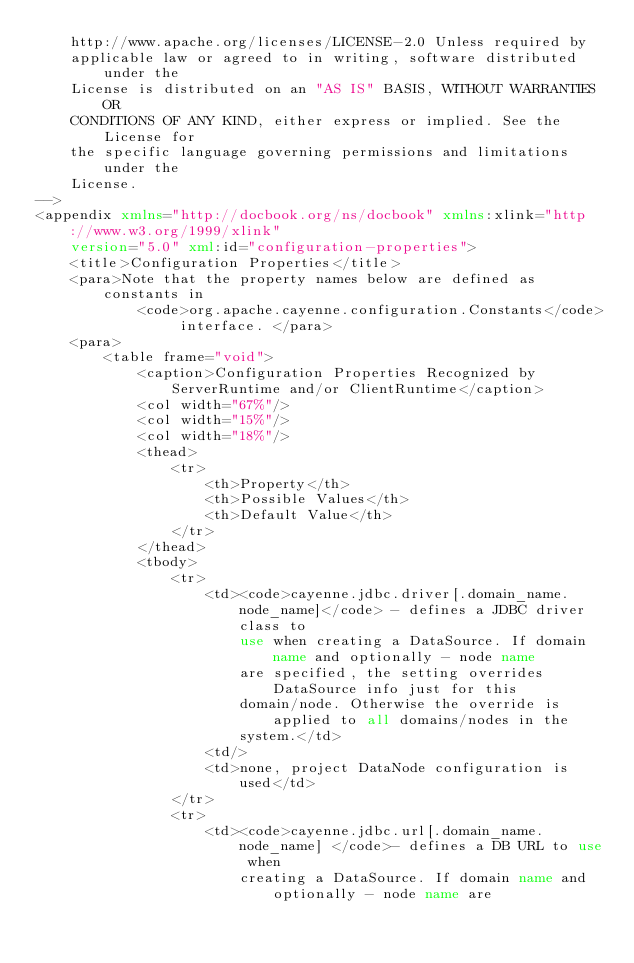Convert code to text. <code><loc_0><loc_0><loc_500><loc_500><_XML_>    http://www.apache.org/licenses/LICENSE-2.0 Unless required by
    applicable law or agreed to in writing, software distributed under the
    License is distributed on an "AS IS" BASIS, WITHOUT WARRANTIES OR
    CONDITIONS OF ANY KIND, either express or implied. See the License for
    the specific language governing permissions and limitations under the
    License.
-->
<appendix xmlns="http://docbook.org/ns/docbook" xmlns:xlink="http://www.w3.org/1999/xlink"
    version="5.0" xml:id="configuration-properties">
    <title>Configuration Properties</title>
    <para>Note that the property names below are defined as constants in
            <code>org.apache.cayenne.configuration.Constants</code> interface. </para>
    <para>
        <table frame="void">
            <caption>Configuration Properties Recognized by ServerRuntime and/or ClientRuntime</caption>
            <col width="67%"/>
            <col width="15%"/>
            <col width="18%"/>
            <thead>
                <tr>
                    <th>Property</th>
                    <th>Possible Values</th>
                    <th>Default Value</th>
                </tr>
            </thead>
            <tbody>
                <tr>
                    <td><code>cayenne.jdbc.driver[.domain_name.node_name]</code> - defines a JDBC driver class to
                        use when creating a DataSource. If domain name and optionally - node name
                        are specified, the setting overrides DataSource info just for this
                        domain/node. Otherwise the override is applied to all domains/nodes in the
                        system.</td>
                    <td/>
                    <td>none, project DataNode configuration is used</td>
                </tr>
                <tr>
                    <td><code>cayenne.jdbc.url[.domain_name.node_name] </code>- defines a DB URL to use when
                        creating a DataSource. If domain name and optionally - node name are</code> 